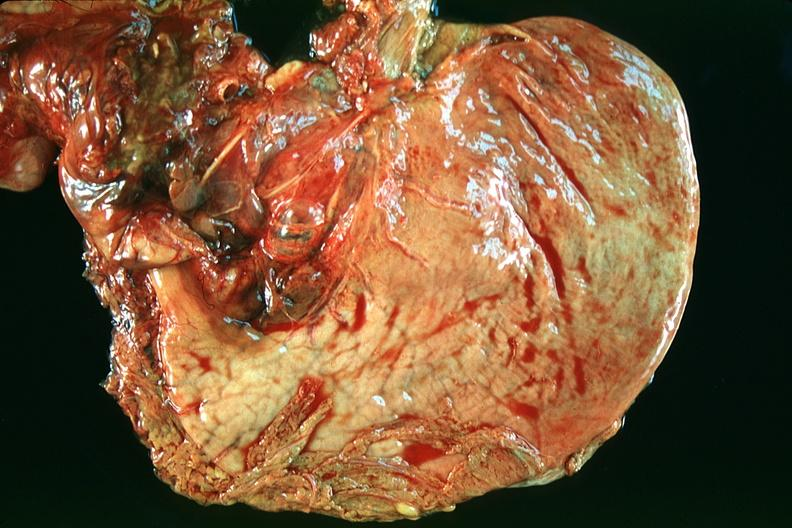does this image show normal stomach?
Answer the question using a single word or phrase. Yes 